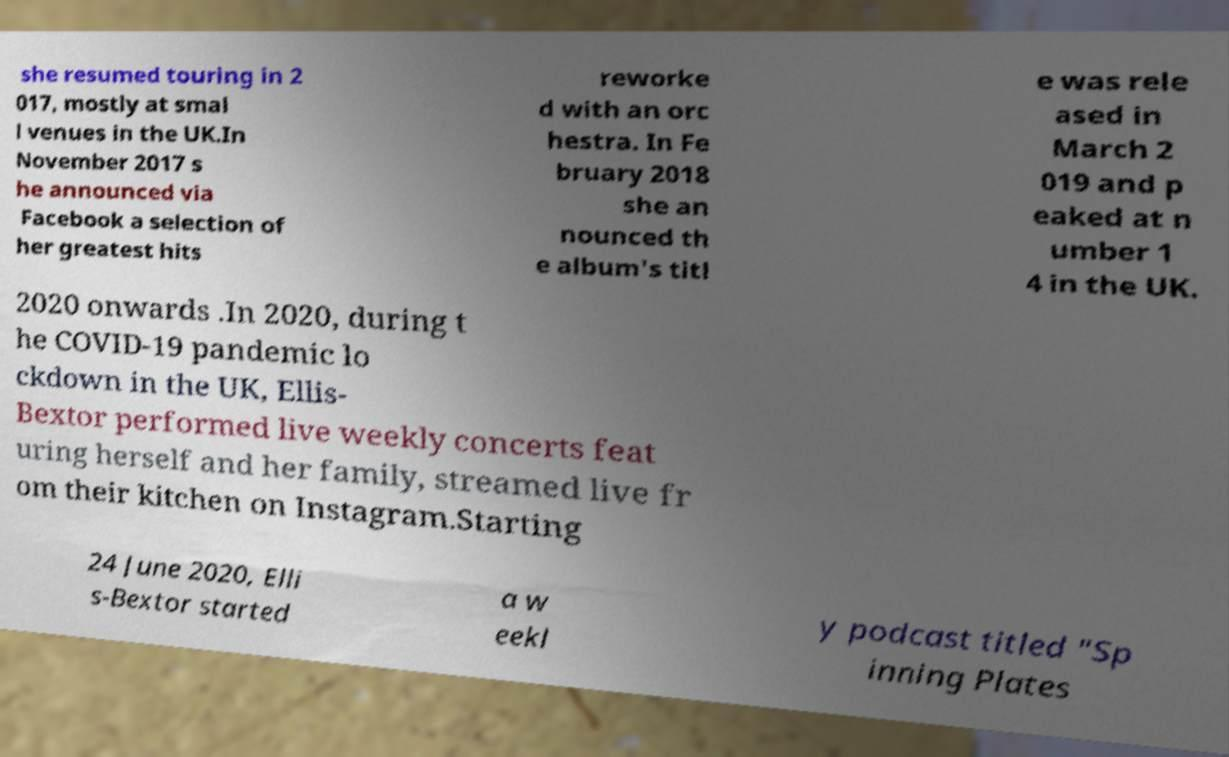Can you read and provide the text displayed in the image?This photo seems to have some interesting text. Can you extract and type it out for me? she resumed touring in 2 017, mostly at smal l venues in the UK.In November 2017 s he announced via Facebook a selection of her greatest hits reworke d with an orc hestra. In Fe bruary 2018 she an nounced th e album's titl e was rele ased in March 2 019 and p eaked at n umber 1 4 in the UK. 2020 onwards .In 2020, during t he COVID-19 pandemic lo ckdown in the UK, Ellis- Bextor performed live weekly concerts feat uring herself and her family, streamed live fr om their kitchen on Instagram.Starting 24 June 2020, Elli s-Bextor started a w eekl y podcast titled "Sp inning Plates 